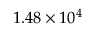Convert formula to latex. <formula><loc_0><loc_0><loc_500><loc_500>1 . 4 8 \times 1 0 ^ { 4 }</formula> 